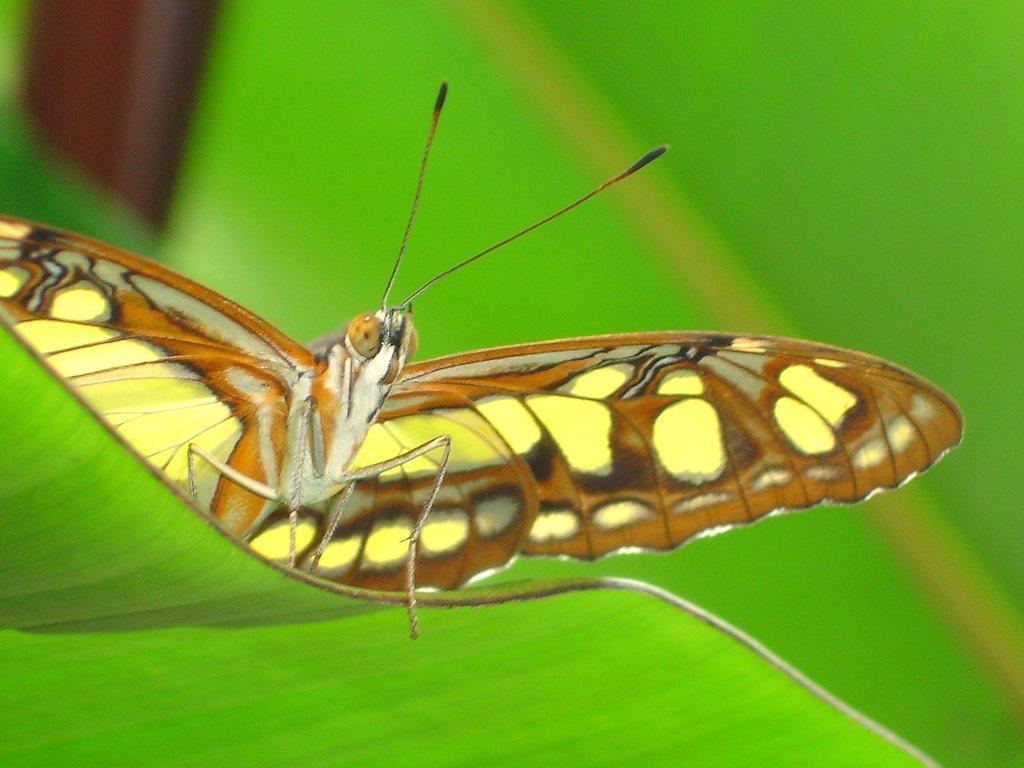In one or two sentences, can you explain what this image depicts? In this image we can see a butterfly on a leaf. 